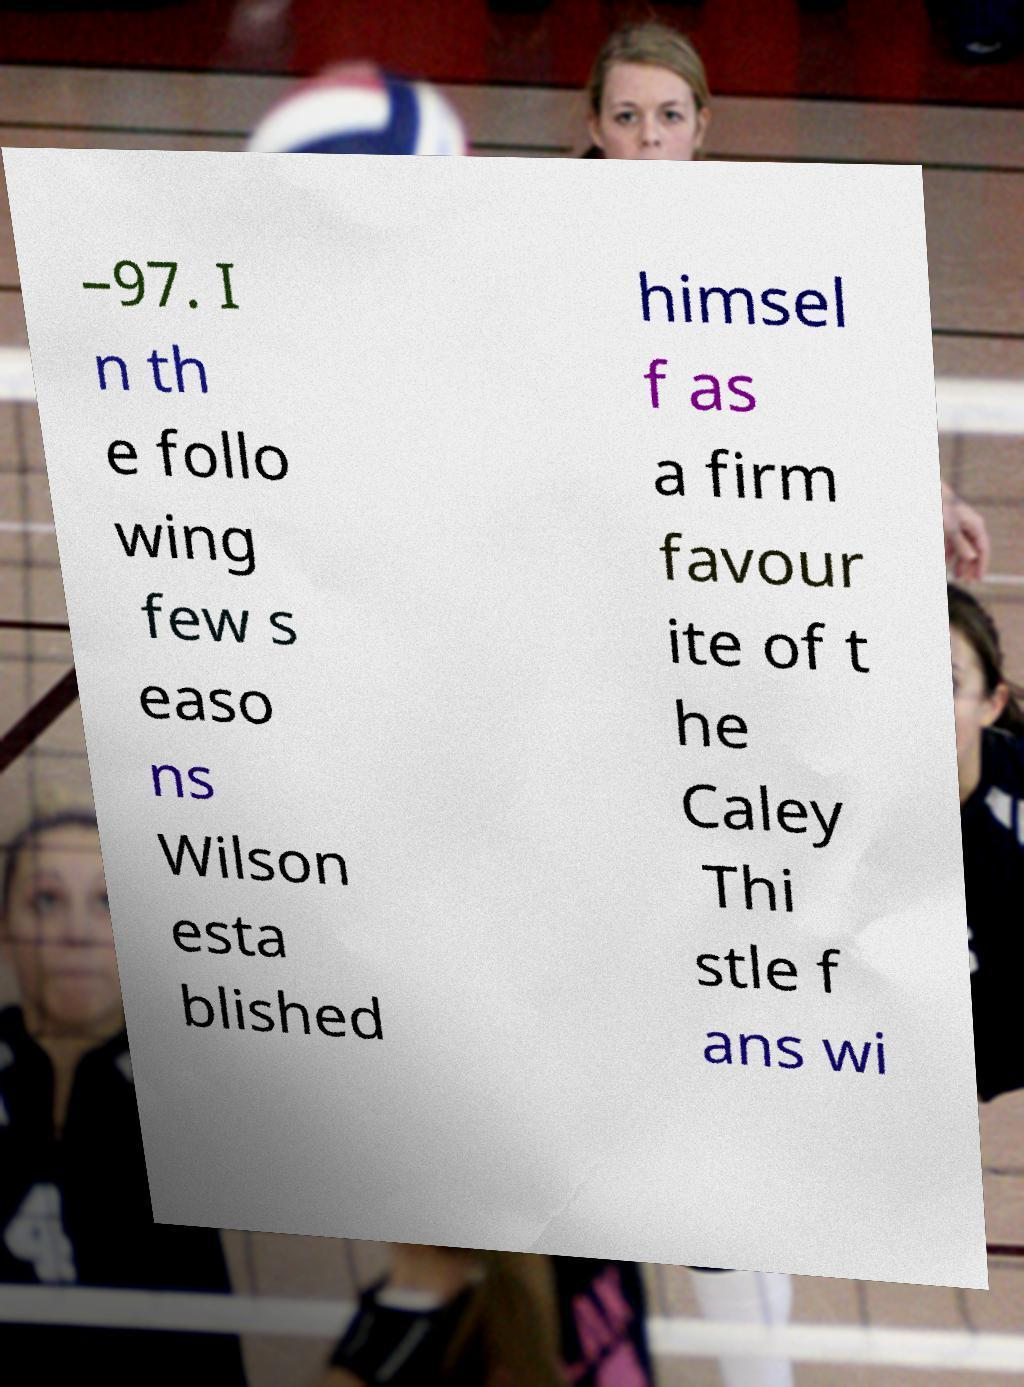What messages or text are displayed in this image? I need them in a readable, typed format. –97. I n th e follo wing few s easo ns Wilson esta blished himsel f as a firm favour ite of t he Caley Thi stle f ans wi 